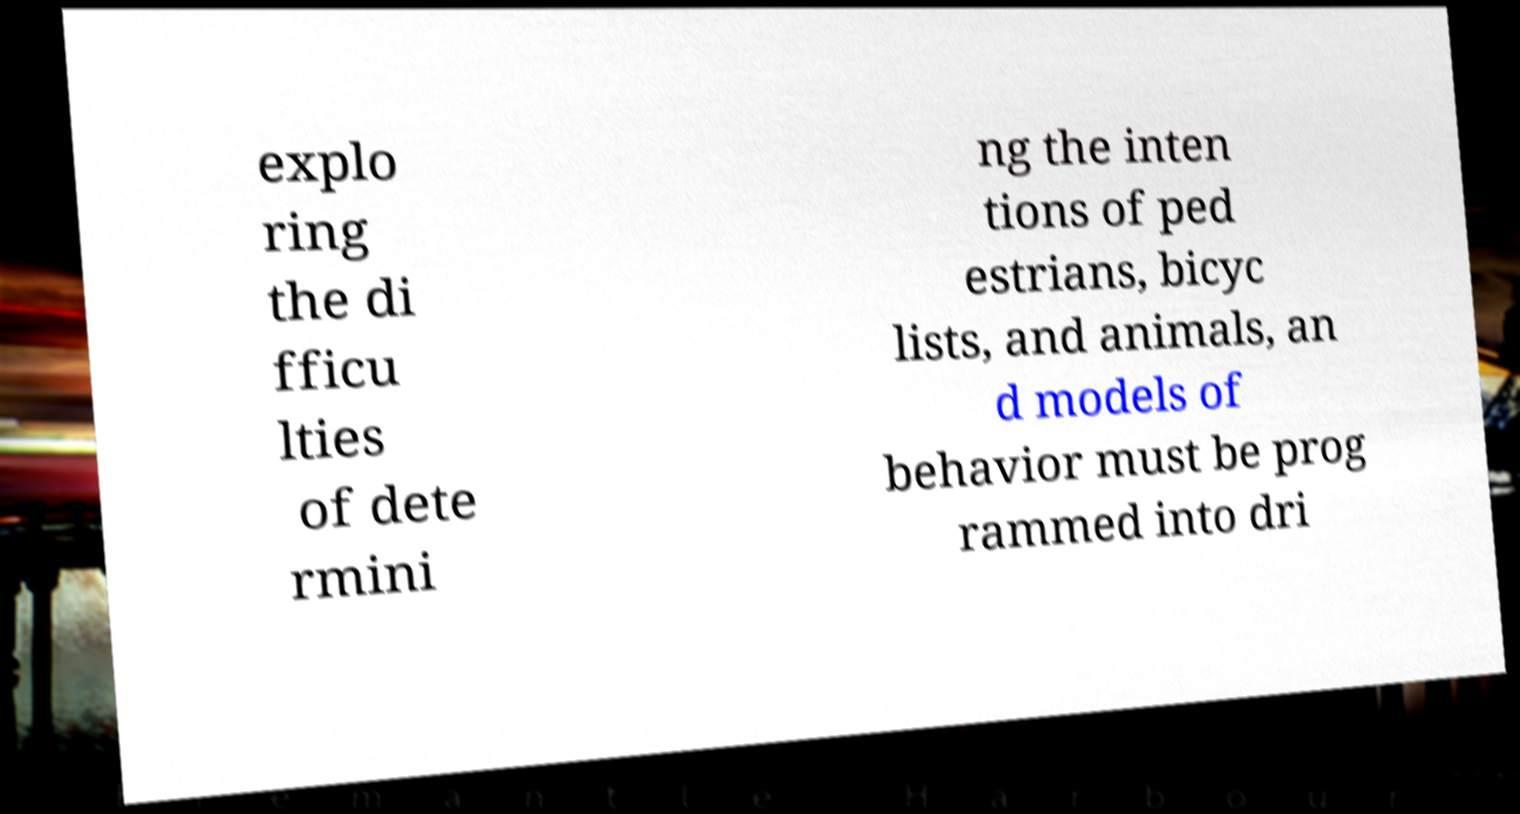Please identify and transcribe the text found in this image. explo ring the di fficu lties of dete rmini ng the inten tions of ped estrians, bicyc lists, and animals, an d models of behavior must be prog rammed into dri 